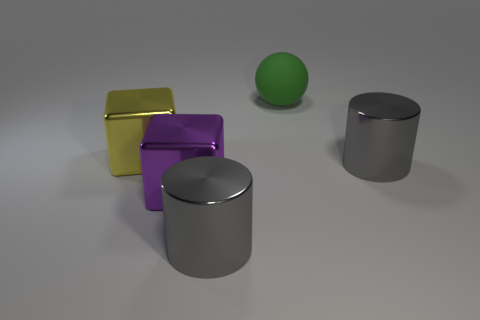What number of big shiny things have the same color as the large matte object?
Provide a succinct answer. 0. There is another big metallic thing that is the same shape as the yellow object; what color is it?
Keep it short and to the point. Purple. There is a big object that is both right of the purple thing and on the left side of the big green object; what is its material?
Provide a short and direct response. Metal. Is the material of the large yellow thing that is left of the purple metallic cube the same as the gray cylinder that is to the right of the rubber object?
Your answer should be very brief. Yes. The green sphere is what size?
Your answer should be compact. Large. What is the size of the yellow metal thing that is the same shape as the purple metal thing?
Make the answer very short. Large. There is a purple block; what number of large matte spheres are in front of it?
Offer a very short reply. 0. There is a object behind the big shiny cube to the left of the large purple metallic block; what color is it?
Keep it short and to the point. Green. Is there any other thing that has the same shape as the green rubber thing?
Offer a very short reply. No. Are there an equal number of yellow blocks that are in front of the big purple shiny object and large green matte spheres that are in front of the yellow block?
Your answer should be very brief. Yes. 